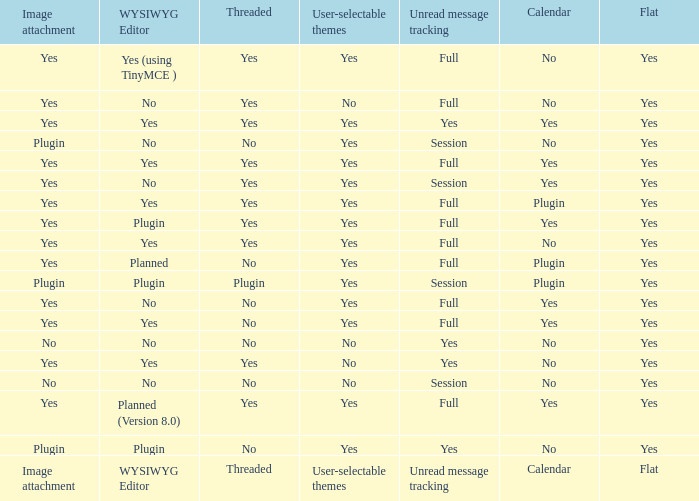Which Image attachment has a Threaded of yes, and a Calendar of yes? Yes, Yes, Yes, Yes, Yes. 